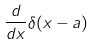<formula> <loc_0><loc_0><loc_500><loc_500>\frac { d } { d x } \delta ( x - a )</formula> 